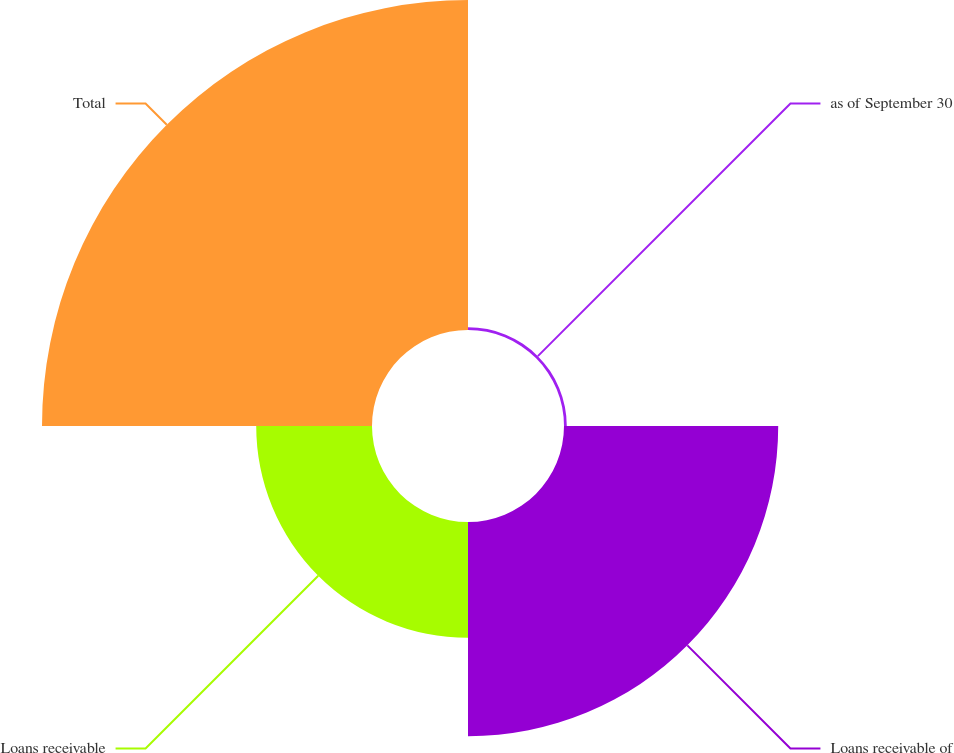Convert chart to OTSL. <chart><loc_0><loc_0><loc_500><loc_500><pie_chart><fcel>as of September 30<fcel>Loans receivable of<fcel>Loans receivable<fcel>Total<nl><fcel>0.42%<fcel>32.32%<fcel>17.47%<fcel>49.79%<nl></chart> 